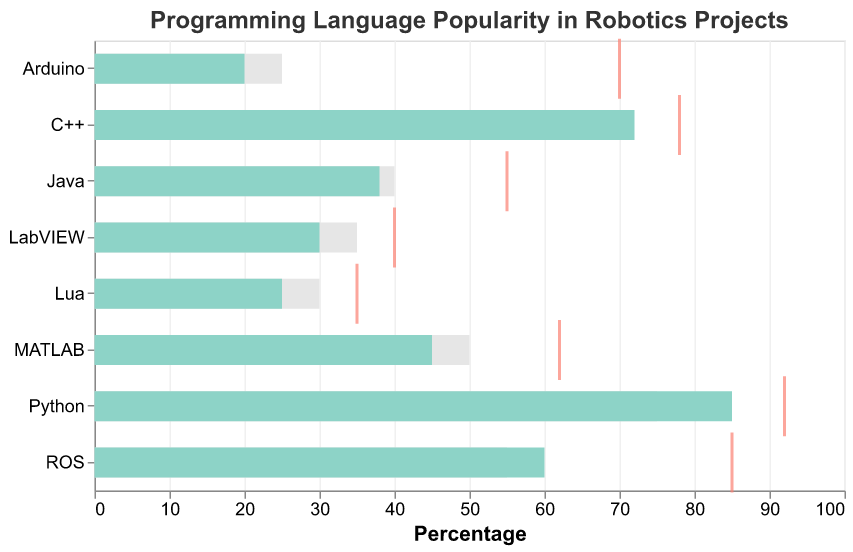What is the title of the figure? The title is displayed at the top of the chart in a larger font and is designed to give a quick understanding of what the figure represents.
Answer: Programming Language Popularity in Robotics Projects How does the Community Engagement of Arduino compare to its Adoption Rate? By looking at the bar and tick for Arduino, we see that the Community Engagement (70) is significantly higher than its Adoption Rate (20).
Answer: Community Engagement is higher Which language has the highest Adoption Rate, and what is that rate? Observing the lengths of the bars representing Adoption Rates, Python has the longest bar. The bar reaches up to 85.
Answer: Python, 85 Which language's Adoption Rate is below the Industry Average but has high Community Engagement? ROS has an Adoption Rate (60) below the Industry Average (55), but its Community Engagement (85) is the second highest.
Answer: ROS What is the difference in Adoption Rates between Python and Java? The Adoption Rate for Python is 85, and for Java, it is 38. The difference is calculated by subtracting Java's rate from Python's rate: 85 - 38 = 47.
Answer: 47 Does LabVIEW have a higher or lower Adoption Rate compared to the Industry Average? LabVIEW's Adoption Rate is 30, while the Industry Average is 35. Since 30 is less than 35, LabVIEW's Adoption Rate is lower.
Answer: Lower Which language has the lowest Community Engagement, and what is that value? The shortest tick mark represents the lowest Community Engagement, belonging to Lua with a value of 35.
Answer: Lua, 35 Compare the Adoption Rates and Industry Averages of C++ and ROS. Which language performs better in both categories? C++ has an Adoption Rate of 72 and Industry Average of 70, while ROS has an Adoption Rate of 60 and Industry Average of 55. C++ performs better in both categories as both its Adoption Rate and Industry Average are higher.
Answer: C++ What is the average Adoption Rate for all the languages listed? To find the average, add all the Adoption Rates (85+72+60+45+38+30+25+20) = 375, and then divide by the number of languages (8). The average is 375/8 = 46.875.
Answer: 46.875 Which language shows the highest discrepancy between its Adoption Rate and Community Engagement? To identify the highest discrepancy, calculate the absolute difference for each language. Python (92-85=7), C++ (78-72=6), ROS (85-60=25), MATLAB (62-45=17), Java (55-38=17), LabVIEW (40-30=10), Lua (35-25=10), Arduino (70-20=50). Arduino has the highest discrepancy of 50.
Answer: Arduino 